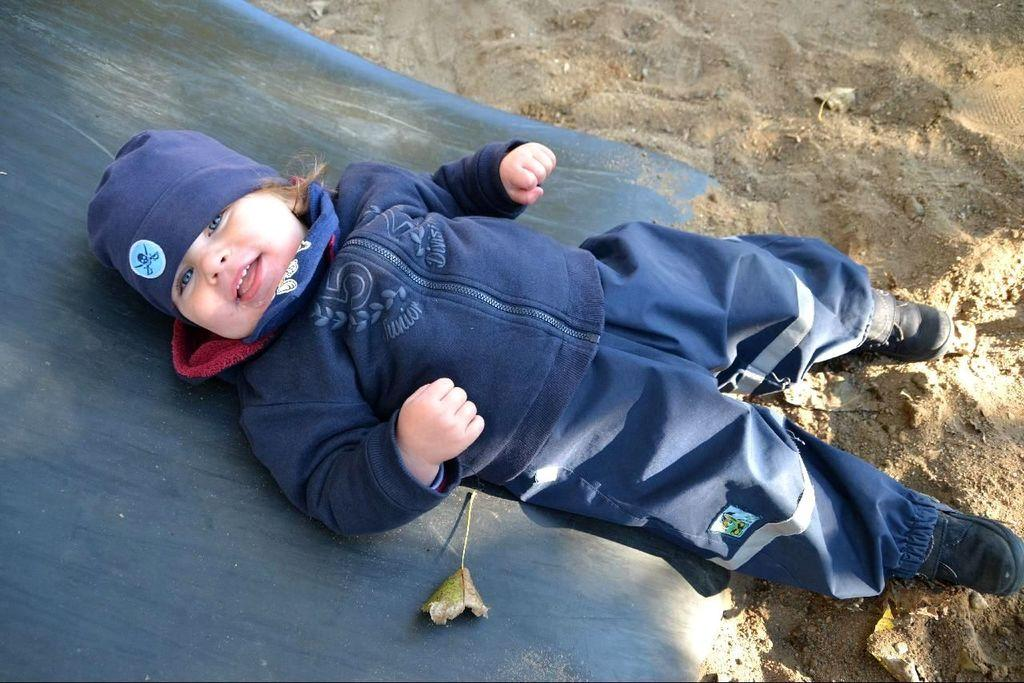What is the main subject of the image? The main subject of the image is a kid. What is the kid doing in the image? The kid is sleeping on a slide. Where is the slide located? The slide is on the sand. What type of clothing is the kid wearing? The kid is wearing a sweater and a cap. What type of wire can be seen tangled around the kid's legs in the image? There is no wire tangled around the kid's legs in the image. Can you describe the ball that the kid is playing with in the image? There is no ball present in the image; the kid is sleeping on a slide. 